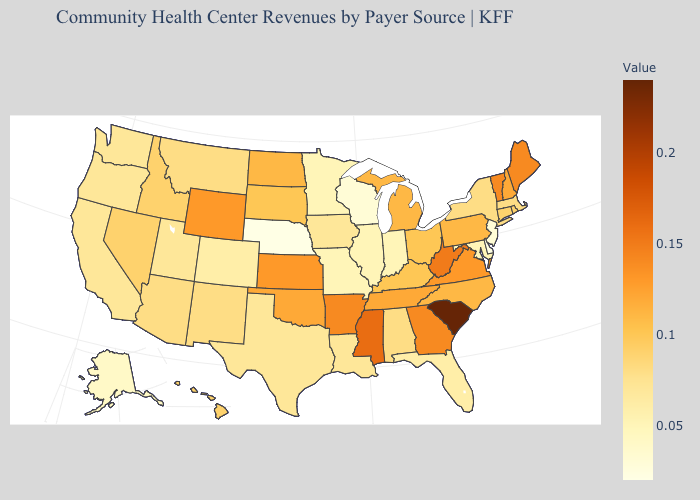Which states have the highest value in the USA?
Short answer required. South Carolina. Which states have the lowest value in the Northeast?
Short answer required. New Jersey. Does the map have missing data?
Quick response, please. No. Does Georgia have a higher value than California?
Give a very brief answer. Yes. 